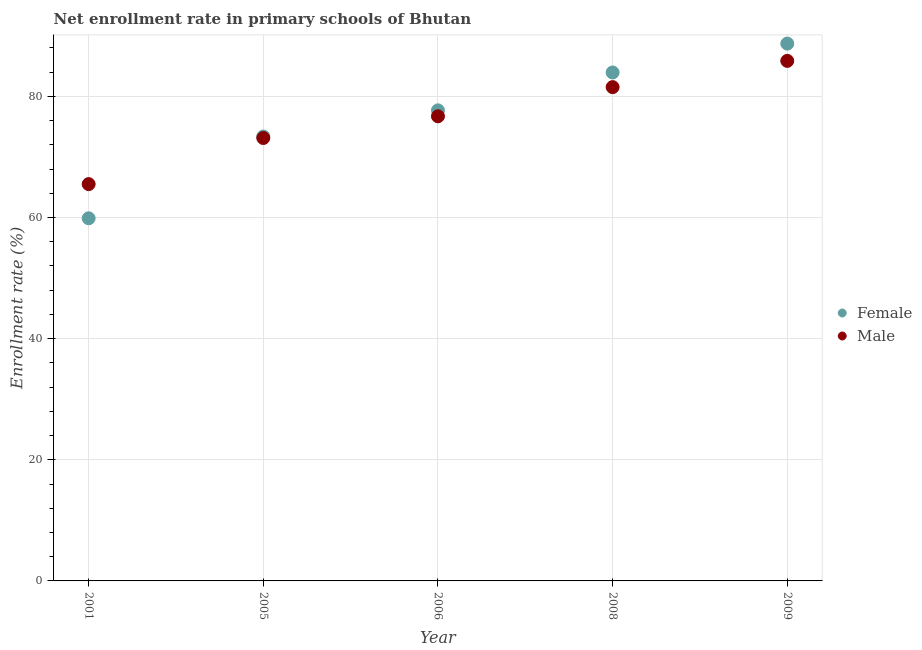How many different coloured dotlines are there?
Offer a terse response. 2. What is the enrollment rate of female students in 2005?
Make the answer very short. 73.38. Across all years, what is the maximum enrollment rate of male students?
Offer a terse response. 85.87. Across all years, what is the minimum enrollment rate of female students?
Make the answer very short. 59.88. In which year was the enrollment rate of female students maximum?
Your answer should be compact. 2009. In which year was the enrollment rate of female students minimum?
Ensure brevity in your answer.  2001. What is the total enrollment rate of male students in the graph?
Your response must be concise. 382.77. What is the difference between the enrollment rate of female students in 2006 and that in 2008?
Your response must be concise. -6.25. What is the difference between the enrollment rate of male students in 2008 and the enrollment rate of female students in 2009?
Your response must be concise. -7.19. What is the average enrollment rate of female students per year?
Ensure brevity in your answer.  76.73. In the year 2005, what is the difference between the enrollment rate of male students and enrollment rate of female students?
Offer a very short reply. -0.24. What is the ratio of the enrollment rate of male students in 2001 to that in 2008?
Offer a very short reply. 0.8. Is the enrollment rate of female students in 2005 less than that in 2009?
Offer a very short reply. Yes. What is the difference between the highest and the second highest enrollment rate of female students?
Your response must be concise. 4.76. What is the difference between the highest and the lowest enrollment rate of male students?
Make the answer very short. 20.35. In how many years, is the enrollment rate of male students greater than the average enrollment rate of male students taken over all years?
Keep it short and to the point. 3. Is the enrollment rate of female students strictly greater than the enrollment rate of male students over the years?
Provide a succinct answer. No. Is the enrollment rate of female students strictly less than the enrollment rate of male students over the years?
Provide a succinct answer. No. How many dotlines are there?
Make the answer very short. 2. How many years are there in the graph?
Offer a very short reply. 5. What is the difference between two consecutive major ticks on the Y-axis?
Your answer should be compact. 20. Does the graph contain any zero values?
Offer a terse response. No. Does the graph contain grids?
Provide a short and direct response. Yes. What is the title of the graph?
Make the answer very short. Net enrollment rate in primary schools of Bhutan. What is the label or title of the X-axis?
Keep it short and to the point. Year. What is the label or title of the Y-axis?
Your answer should be compact. Enrollment rate (%). What is the Enrollment rate (%) of Female in 2001?
Offer a terse response. 59.88. What is the Enrollment rate (%) in Male in 2001?
Provide a succinct answer. 65.52. What is the Enrollment rate (%) in Female in 2005?
Provide a succinct answer. 73.38. What is the Enrollment rate (%) of Male in 2005?
Your answer should be compact. 73.13. What is the Enrollment rate (%) in Female in 2006?
Offer a terse response. 77.7. What is the Enrollment rate (%) in Male in 2006?
Offer a terse response. 76.72. What is the Enrollment rate (%) of Female in 2008?
Your answer should be very brief. 83.95. What is the Enrollment rate (%) of Male in 2008?
Offer a terse response. 81.53. What is the Enrollment rate (%) of Female in 2009?
Make the answer very short. 88.72. What is the Enrollment rate (%) in Male in 2009?
Provide a short and direct response. 85.87. Across all years, what is the maximum Enrollment rate (%) of Female?
Keep it short and to the point. 88.72. Across all years, what is the maximum Enrollment rate (%) in Male?
Keep it short and to the point. 85.87. Across all years, what is the minimum Enrollment rate (%) in Female?
Your answer should be compact. 59.88. Across all years, what is the minimum Enrollment rate (%) of Male?
Your response must be concise. 65.52. What is the total Enrollment rate (%) in Female in the graph?
Ensure brevity in your answer.  383.63. What is the total Enrollment rate (%) in Male in the graph?
Your response must be concise. 382.77. What is the difference between the Enrollment rate (%) of Female in 2001 and that in 2005?
Provide a short and direct response. -13.5. What is the difference between the Enrollment rate (%) of Male in 2001 and that in 2005?
Provide a succinct answer. -7.61. What is the difference between the Enrollment rate (%) in Female in 2001 and that in 2006?
Keep it short and to the point. -17.82. What is the difference between the Enrollment rate (%) of Male in 2001 and that in 2006?
Provide a succinct answer. -11.2. What is the difference between the Enrollment rate (%) in Female in 2001 and that in 2008?
Offer a very short reply. -24.08. What is the difference between the Enrollment rate (%) of Male in 2001 and that in 2008?
Provide a short and direct response. -16.01. What is the difference between the Enrollment rate (%) in Female in 2001 and that in 2009?
Give a very brief answer. -28.84. What is the difference between the Enrollment rate (%) of Male in 2001 and that in 2009?
Offer a terse response. -20.35. What is the difference between the Enrollment rate (%) in Female in 2005 and that in 2006?
Give a very brief answer. -4.32. What is the difference between the Enrollment rate (%) in Male in 2005 and that in 2006?
Make the answer very short. -3.59. What is the difference between the Enrollment rate (%) of Female in 2005 and that in 2008?
Offer a very short reply. -10.58. What is the difference between the Enrollment rate (%) in Male in 2005 and that in 2008?
Offer a very short reply. -8.4. What is the difference between the Enrollment rate (%) in Female in 2005 and that in 2009?
Offer a terse response. -15.34. What is the difference between the Enrollment rate (%) of Male in 2005 and that in 2009?
Your answer should be compact. -12.73. What is the difference between the Enrollment rate (%) in Female in 2006 and that in 2008?
Your response must be concise. -6.25. What is the difference between the Enrollment rate (%) in Male in 2006 and that in 2008?
Keep it short and to the point. -4.82. What is the difference between the Enrollment rate (%) in Female in 2006 and that in 2009?
Give a very brief answer. -11.02. What is the difference between the Enrollment rate (%) of Male in 2006 and that in 2009?
Provide a succinct answer. -9.15. What is the difference between the Enrollment rate (%) in Female in 2008 and that in 2009?
Offer a very short reply. -4.76. What is the difference between the Enrollment rate (%) of Male in 2008 and that in 2009?
Provide a succinct answer. -4.33. What is the difference between the Enrollment rate (%) in Female in 2001 and the Enrollment rate (%) in Male in 2005?
Give a very brief answer. -13.26. What is the difference between the Enrollment rate (%) of Female in 2001 and the Enrollment rate (%) of Male in 2006?
Give a very brief answer. -16.84. What is the difference between the Enrollment rate (%) in Female in 2001 and the Enrollment rate (%) in Male in 2008?
Provide a short and direct response. -21.66. What is the difference between the Enrollment rate (%) in Female in 2001 and the Enrollment rate (%) in Male in 2009?
Make the answer very short. -25.99. What is the difference between the Enrollment rate (%) in Female in 2005 and the Enrollment rate (%) in Male in 2006?
Your response must be concise. -3.34. What is the difference between the Enrollment rate (%) of Female in 2005 and the Enrollment rate (%) of Male in 2008?
Keep it short and to the point. -8.16. What is the difference between the Enrollment rate (%) of Female in 2005 and the Enrollment rate (%) of Male in 2009?
Keep it short and to the point. -12.49. What is the difference between the Enrollment rate (%) in Female in 2006 and the Enrollment rate (%) in Male in 2008?
Your answer should be very brief. -3.83. What is the difference between the Enrollment rate (%) of Female in 2006 and the Enrollment rate (%) of Male in 2009?
Offer a terse response. -8.16. What is the difference between the Enrollment rate (%) of Female in 2008 and the Enrollment rate (%) of Male in 2009?
Provide a short and direct response. -1.91. What is the average Enrollment rate (%) of Female per year?
Give a very brief answer. 76.73. What is the average Enrollment rate (%) in Male per year?
Your response must be concise. 76.55. In the year 2001, what is the difference between the Enrollment rate (%) in Female and Enrollment rate (%) in Male?
Provide a short and direct response. -5.64. In the year 2005, what is the difference between the Enrollment rate (%) of Female and Enrollment rate (%) of Male?
Make the answer very short. 0.24. In the year 2006, what is the difference between the Enrollment rate (%) of Female and Enrollment rate (%) of Male?
Ensure brevity in your answer.  0.98. In the year 2008, what is the difference between the Enrollment rate (%) of Female and Enrollment rate (%) of Male?
Provide a succinct answer. 2.42. In the year 2009, what is the difference between the Enrollment rate (%) of Female and Enrollment rate (%) of Male?
Your answer should be very brief. 2.85. What is the ratio of the Enrollment rate (%) in Female in 2001 to that in 2005?
Your answer should be compact. 0.82. What is the ratio of the Enrollment rate (%) in Male in 2001 to that in 2005?
Your answer should be very brief. 0.9. What is the ratio of the Enrollment rate (%) in Female in 2001 to that in 2006?
Provide a succinct answer. 0.77. What is the ratio of the Enrollment rate (%) in Male in 2001 to that in 2006?
Ensure brevity in your answer.  0.85. What is the ratio of the Enrollment rate (%) of Female in 2001 to that in 2008?
Keep it short and to the point. 0.71. What is the ratio of the Enrollment rate (%) in Male in 2001 to that in 2008?
Your answer should be very brief. 0.8. What is the ratio of the Enrollment rate (%) of Female in 2001 to that in 2009?
Offer a very short reply. 0.67. What is the ratio of the Enrollment rate (%) in Male in 2001 to that in 2009?
Offer a terse response. 0.76. What is the ratio of the Enrollment rate (%) of Male in 2005 to that in 2006?
Your answer should be compact. 0.95. What is the ratio of the Enrollment rate (%) of Female in 2005 to that in 2008?
Make the answer very short. 0.87. What is the ratio of the Enrollment rate (%) of Male in 2005 to that in 2008?
Your answer should be compact. 0.9. What is the ratio of the Enrollment rate (%) of Female in 2005 to that in 2009?
Your answer should be very brief. 0.83. What is the ratio of the Enrollment rate (%) of Male in 2005 to that in 2009?
Ensure brevity in your answer.  0.85. What is the ratio of the Enrollment rate (%) in Female in 2006 to that in 2008?
Your answer should be very brief. 0.93. What is the ratio of the Enrollment rate (%) of Male in 2006 to that in 2008?
Ensure brevity in your answer.  0.94. What is the ratio of the Enrollment rate (%) of Female in 2006 to that in 2009?
Your response must be concise. 0.88. What is the ratio of the Enrollment rate (%) in Male in 2006 to that in 2009?
Offer a terse response. 0.89. What is the ratio of the Enrollment rate (%) of Female in 2008 to that in 2009?
Your answer should be very brief. 0.95. What is the ratio of the Enrollment rate (%) in Male in 2008 to that in 2009?
Your answer should be very brief. 0.95. What is the difference between the highest and the second highest Enrollment rate (%) in Female?
Make the answer very short. 4.76. What is the difference between the highest and the second highest Enrollment rate (%) of Male?
Provide a short and direct response. 4.33. What is the difference between the highest and the lowest Enrollment rate (%) in Female?
Ensure brevity in your answer.  28.84. What is the difference between the highest and the lowest Enrollment rate (%) in Male?
Your answer should be very brief. 20.35. 